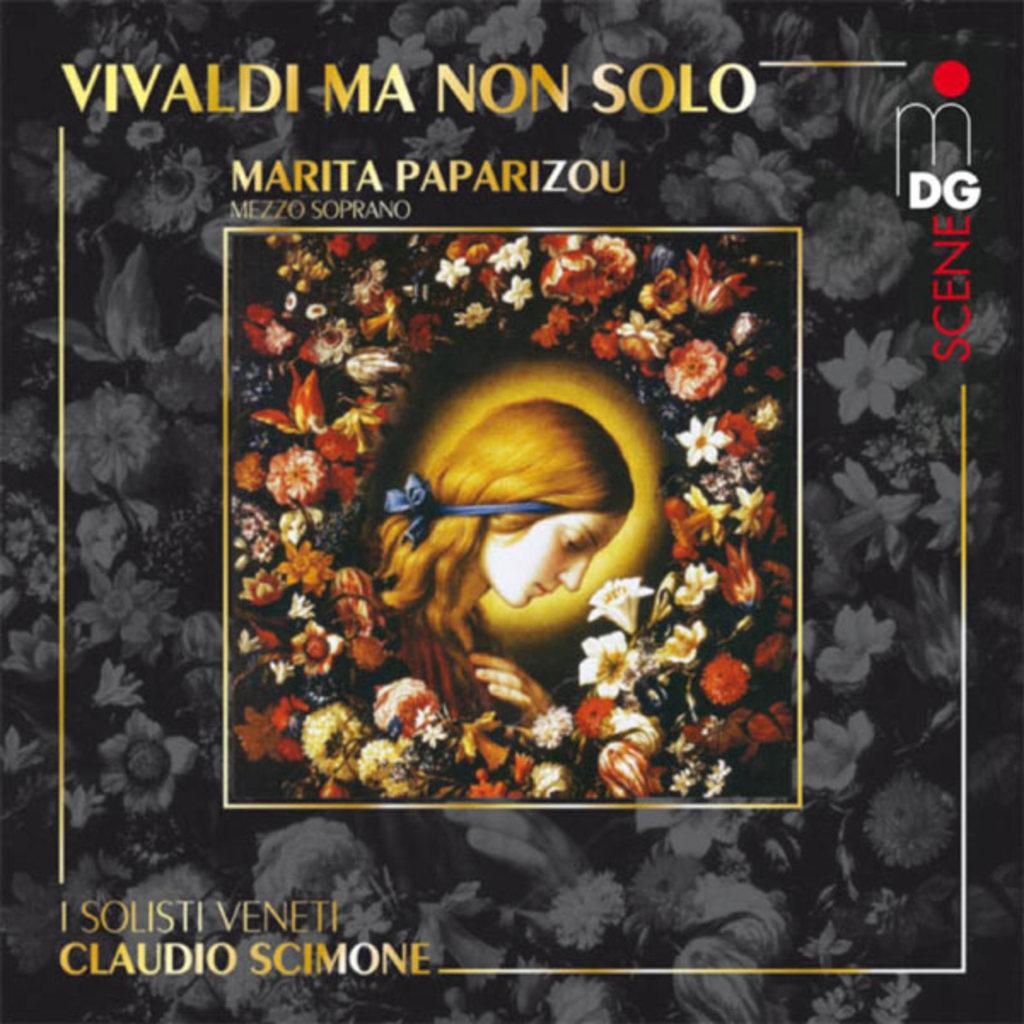How would you summarize this image in a sentence or two? This picture seems to be an edited image. In the center we can see a picture of a person and the picture containing many number of flowers of different colors. In the background we can see the flowers and the hand of a person and we can see the text on the image. 